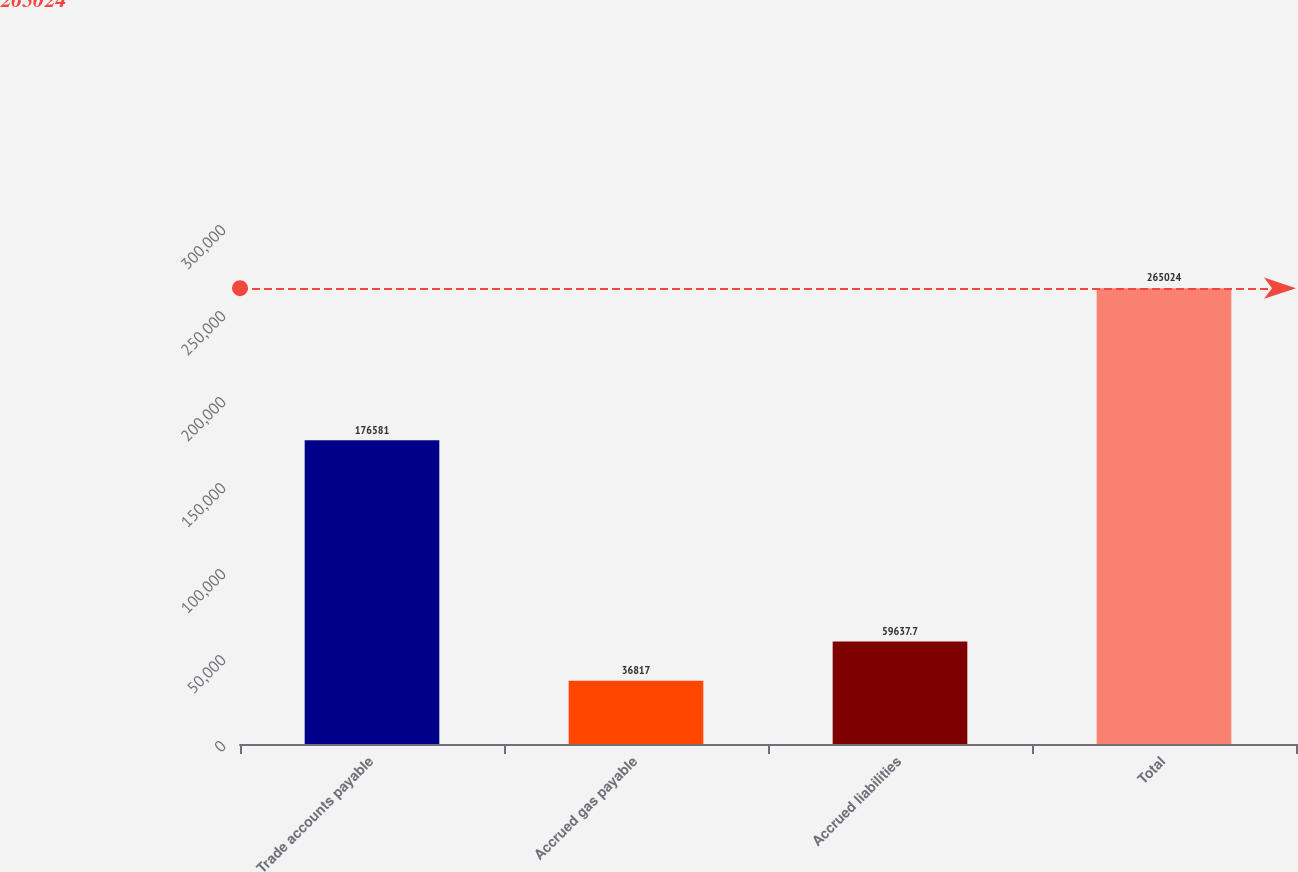Convert chart. <chart><loc_0><loc_0><loc_500><loc_500><bar_chart><fcel>Trade accounts payable<fcel>Accrued gas payable<fcel>Accrued liabilities<fcel>Total<nl><fcel>176581<fcel>36817<fcel>59637.7<fcel>265024<nl></chart> 